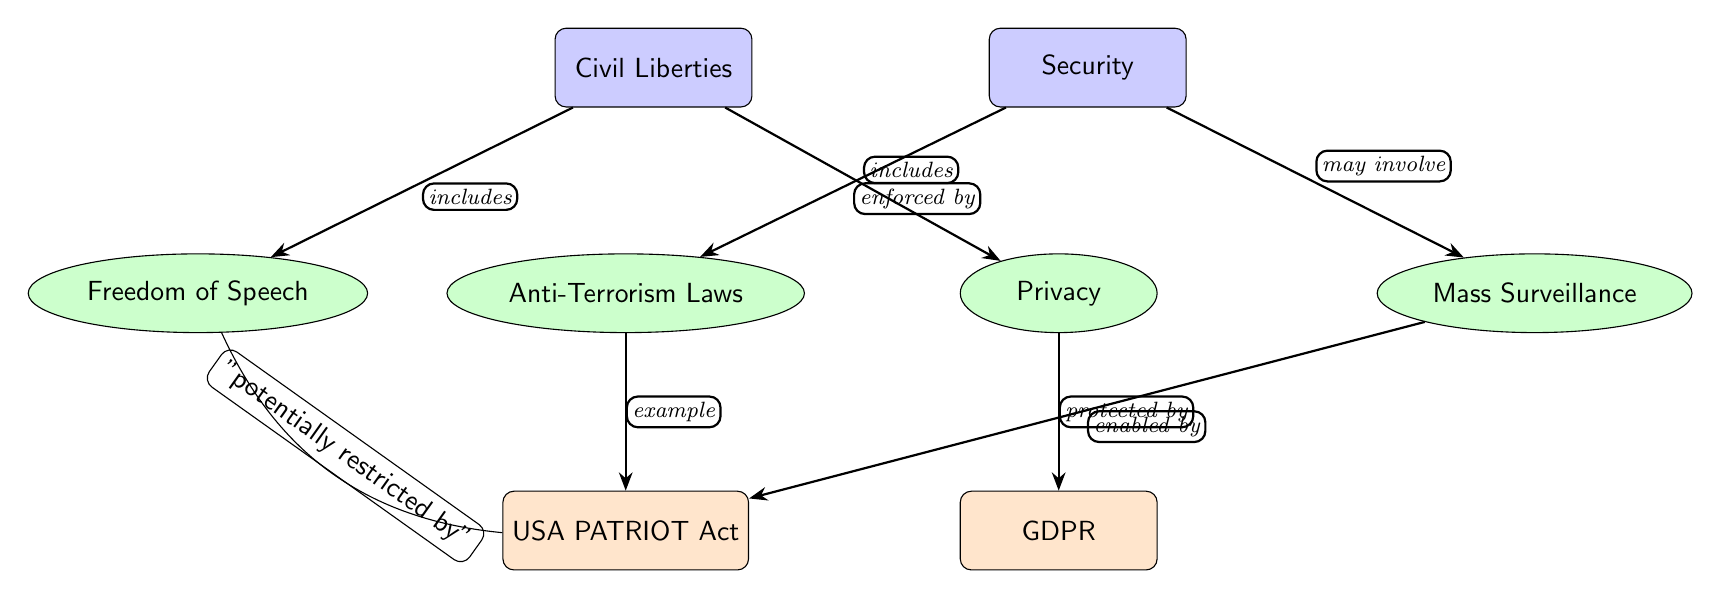What is included in Civil Liberties? The diagram shows that "Freedom of Speech" and "Privacy" are both included under "Civil Liberties". These nodes are directly connected by edges indicating the relationship.
Answer: Freedom of Speech, Privacy What is enforced by Security? The diagram explicitly states that "Anti-Terrorism Laws" are enforced by "Security", as indicated by the edge connecting these two nodes with the label "enforced by".
Answer: Anti-Terrorism Laws How many secondary nodes are in the diagram? By counting, there are four secondary nodes: "Freedom of Speech", "Privacy", "Anti-Terrorism Laws", and "Mass Surveillance". This includes both sides of the main nodes "Civil Liberties" and "Security".
Answer: 4 What protects Privacy? The diagram shows that "GDPR" is protecting "Privacy", which is indicated by the edge connecting these two nodes with the label "protected by".
Answer: GDPR What is an example of Anti-Terrorism Laws? The edge connecting "Anti-Terrorism Laws" to "USA PATRIOT Act" indicates that this act is an example of Anti-Terrorism Laws, as specified by the label on the edge.
Answer: USA PATRIOT Act What may involve Mass Surveillance? The diagram states that "Security" may involve "Mass Surveillance", which is indicated by the edge connecting them with the label "may involve".
Answer: Security Which node is potentially restricted by the USA PATRIOT Act? The edge from "Free Speech" to "USA PATRIOT Act" indicates that "Free Speech" is potentially restricted by this act, as specified by the label on the edge.
Answer: Free Speech What is enabled by the USA PATRIOT Act? The diagram indicates that "Mass Surveillance" is enabled by the "USA PATRIOT Act" as shown by the edge connecting these two nodes with the label "enabled by".
Answer: Mass Surveillance 